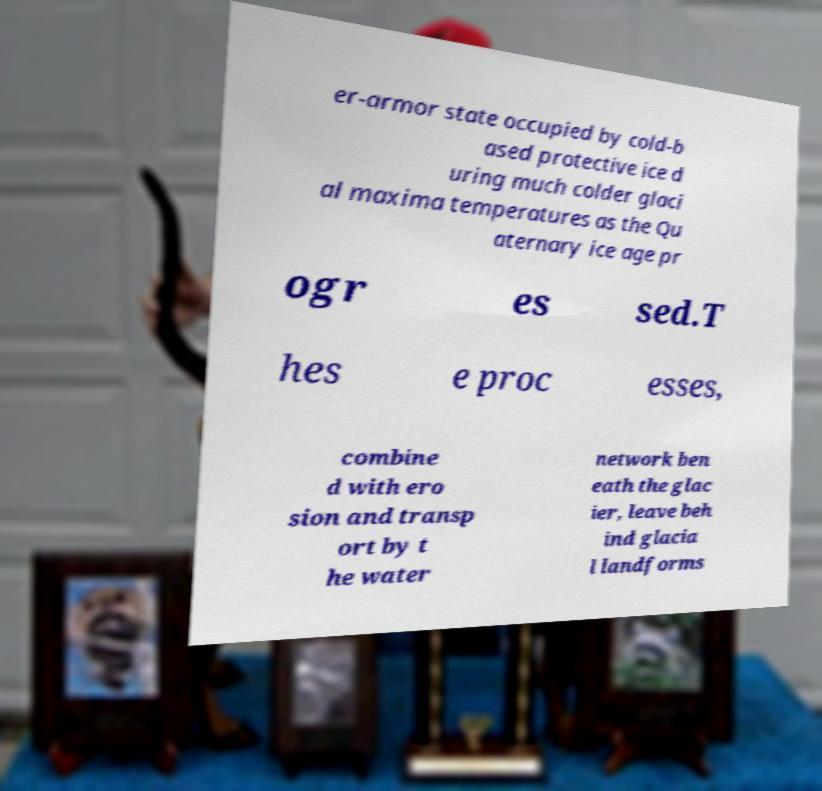Can you accurately transcribe the text from the provided image for me? er-armor state occupied by cold-b ased protective ice d uring much colder glaci al maxima temperatures as the Qu aternary ice age pr ogr es sed.T hes e proc esses, combine d with ero sion and transp ort by t he water network ben eath the glac ier, leave beh ind glacia l landforms 